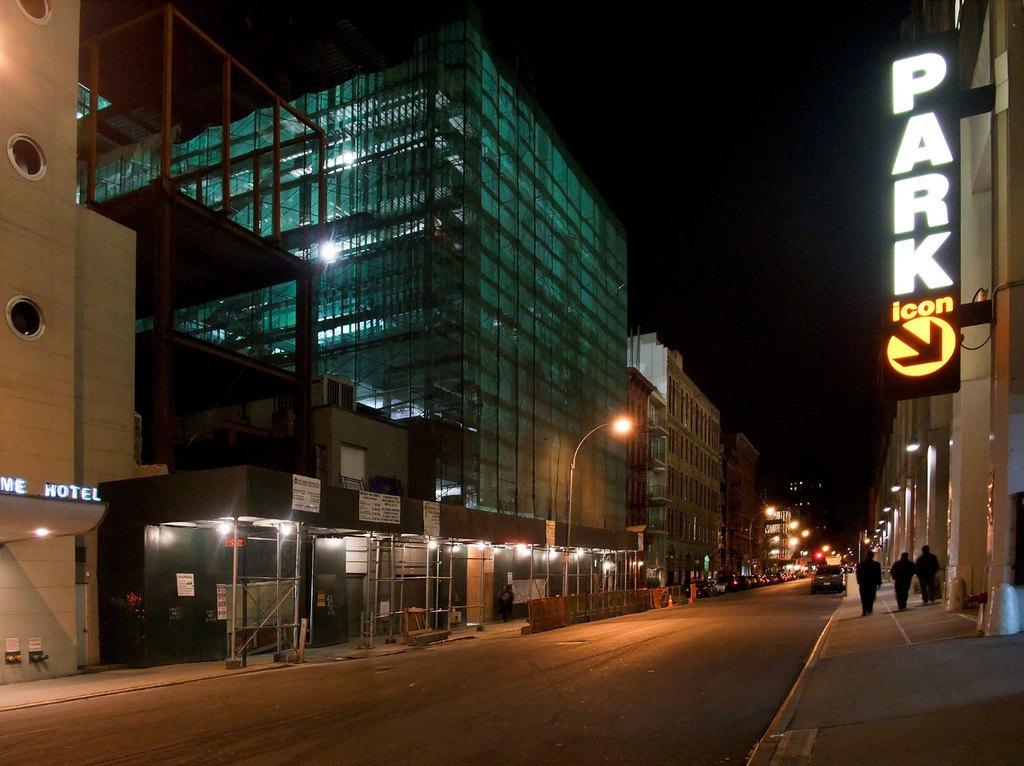In one or two sentences, can you explain what this image depicts? In this picture there are people and we can see car on the road, lights, boards, poles and buildings. In the background of the image it is dark and we can see lights. 